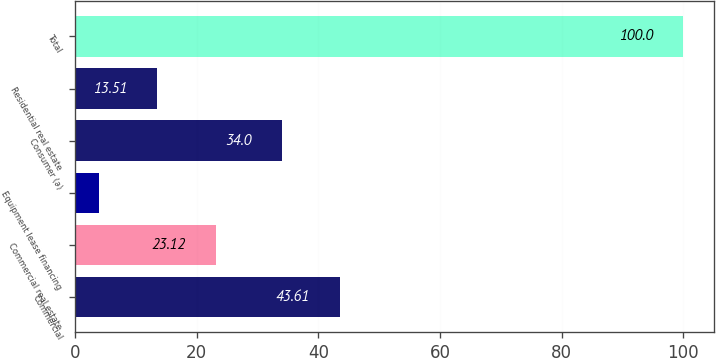Convert chart to OTSL. <chart><loc_0><loc_0><loc_500><loc_500><bar_chart><fcel>Commercial<fcel>Commercial real estate<fcel>Equipment lease financing<fcel>Consumer (a)<fcel>Residential real estate<fcel>Total<nl><fcel>43.61<fcel>23.12<fcel>3.9<fcel>34<fcel>13.51<fcel>100<nl></chart> 